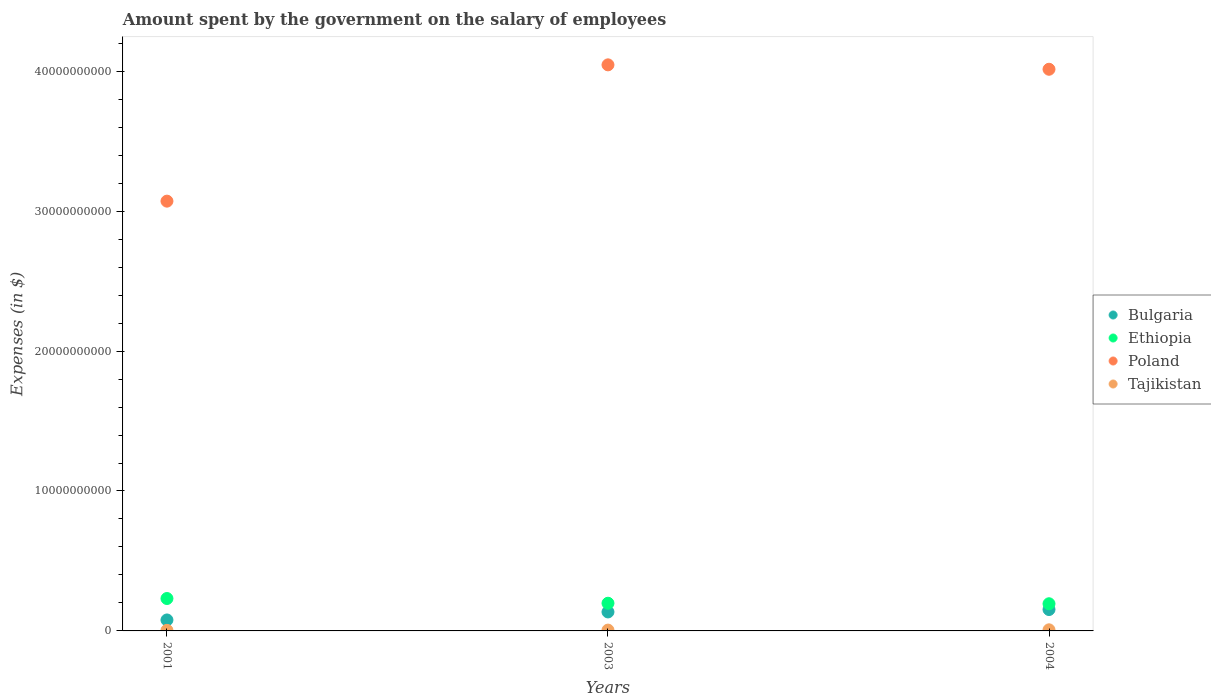Is the number of dotlines equal to the number of legend labels?
Ensure brevity in your answer.  Yes. What is the amount spent on the salary of employees by the government in Poland in 2001?
Make the answer very short. 3.07e+1. Across all years, what is the maximum amount spent on the salary of employees by the government in Tajikistan?
Provide a short and direct response. 7.91e+07. Across all years, what is the minimum amount spent on the salary of employees by the government in Poland?
Ensure brevity in your answer.  3.07e+1. What is the total amount spent on the salary of employees by the government in Poland in the graph?
Ensure brevity in your answer.  1.11e+11. What is the difference between the amount spent on the salary of employees by the government in Poland in 2003 and that in 2004?
Offer a very short reply. 3.15e+08. What is the difference between the amount spent on the salary of employees by the government in Ethiopia in 2004 and the amount spent on the salary of employees by the government in Bulgaria in 2003?
Keep it short and to the point. 5.86e+08. What is the average amount spent on the salary of employees by the government in Bulgaria per year?
Offer a terse response. 1.22e+09. In the year 2001, what is the difference between the amount spent on the salary of employees by the government in Bulgaria and amount spent on the salary of employees by the government in Poland?
Make the answer very short. -2.99e+1. In how many years, is the amount spent on the salary of employees by the government in Tajikistan greater than 34000000000 $?
Keep it short and to the point. 0. What is the ratio of the amount spent on the salary of employees by the government in Tajikistan in 2001 to that in 2003?
Ensure brevity in your answer.  0.69. What is the difference between the highest and the second highest amount spent on the salary of employees by the government in Tajikistan?
Give a very brief answer. 2.00e+07. What is the difference between the highest and the lowest amount spent on the salary of employees by the government in Bulgaria?
Provide a succinct answer. 7.45e+08. In how many years, is the amount spent on the salary of employees by the government in Ethiopia greater than the average amount spent on the salary of employees by the government in Ethiopia taken over all years?
Provide a succinct answer. 1. Is it the case that in every year, the sum of the amount spent on the salary of employees by the government in Ethiopia and amount spent on the salary of employees by the government in Bulgaria  is greater than the sum of amount spent on the salary of employees by the government in Poland and amount spent on the salary of employees by the government in Tajikistan?
Provide a short and direct response. No. Is it the case that in every year, the sum of the amount spent on the salary of employees by the government in Tajikistan and amount spent on the salary of employees by the government in Ethiopia  is greater than the amount spent on the salary of employees by the government in Bulgaria?
Make the answer very short. Yes. Does the amount spent on the salary of employees by the government in Poland monotonically increase over the years?
Offer a very short reply. No. Is the amount spent on the salary of employees by the government in Bulgaria strictly greater than the amount spent on the salary of employees by the government in Poland over the years?
Give a very brief answer. No. Is the amount spent on the salary of employees by the government in Tajikistan strictly less than the amount spent on the salary of employees by the government in Ethiopia over the years?
Your answer should be compact. Yes. What is the difference between two consecutive major ticks on the Y-axis?
Provide a succinct answer. 1.00e+1. Are the values on the major ticks of Y-axis written in scientific E-notation?
Offer a terse response. No. How many legend labels are there?
Ensure brevity in your answer.  4. What is the title of the graph?
Offer a very short reply. Amount spent by the government on the salary of employees. Does "St. Kitts and Nevis" appear as one of the legend labels in the graph?
Give a very brief answer. No. What is the label or title of the Y-axis?
Make the answer very short. Expenses (in $). What is the Expenses (in $) of Bulgaria in 2001?
Offer a very short reply. 7.83e+08. What is the Expenses (in $) in Ethiopia in 2001?
Your answer should be compact. 2.32e+09. What is the Expenses (in $) in Poland in 2001?
Provide a short and direct response. 3.07e+1. What is the Expenses (in $) of Tajikistan in 2001?
Your response must be concise. 4.09e+07. What is the Expenses (in $) in Bulgaria in 2003?
Your answer should be very brief. 1.36e+09. What is the Expenses (in $) in Ethiopia in 2003?
Your response must be concise. 1.98e+09. What is the Expenses (in $) of Poland in 2003?
Make the answer very short. 4.05e+1. What is the Expenses (in $) in Tajikistan in 2003?
Your answer should be compact. 5.91e+07. What is the Expenses (in $) in Bulgaria in 2004?
Your answer should be very brief. 1.53e+09. What is the Expenses (in $) of Ethiopia in 2004?
Ensure brevity in your answer.  1.94e+09. What is the Expenses (in $) in Poland in 2004?
Your answer should be compact. 4.01e+1. What is the Expenses (in $) of Tajikistan in 2004?
Your answer should be compact. 7.91e+07. Across all years, what is the maximum Expenses (in $) of Bulgaria?
Provide a short and direct response. 1.53e+09. Across all years, what is the maximum Expenses (in $) of Ethiopia?
Ensure brevity in your answer.  2.32e+09. Across all years, what is the maximum Expenses (in $) of Poland?
Make the answer very short. 4.05e+1. Across all years, what is the maximum Expenses (in $) of Tajikistan?
Offer a terse response. 7.91e+07. Across all years, what is the minimum Expenses (in $) of Bulgaria?
Provide a short and direct response. 7.83e+08. Across all years, what is the minimum Expenses (in $) of Ethiopia?
Offer a terse response. 1.94e+09. Across all years, what is the minimum Expenses (in $) of Poland?
Make the answer very short. 3.07e+1. Across all years, what is the minimum Expenses (in $) of Tajikistan?
Offer a terse response. 4.09e+07. What is the total Expenses (in $) of Bulgaria in the graph?
Provide a short and direct response. 3.67e+09. What is the total Expenses (in $) in Ethiopia in the graph?
Offer a very short reply. 6.24e+09. What is the total Expenses (in $) in Poland in the graph?
Ensure brevity in your answer.  1.11e+11. What is the total Expenses (in $) of Tajikistan in the graph?
Keep it short and to the point. 1.79e+08. What is the difference between the Expenses (in $) of Bulgaria in 2001 and that in 2003?
Offer a terse response. -5.72e+08. What is the difference between the Expenses (in $) of Ethiopia in 2001 and that in 2003?
Offer a very short reply. 3.38e+08. What is the difference between the Expenses (in $) in Poland in 2001 and that in 2003?
Provide a short and direct response. -9.74e+09. What is the difference between the Expenses (in $) of Tajikistan in 2001 and that in 2003?
Offer a very short reply. -1.82e+07. What is the difference between the Expenses (in $) in Bulgaria in 2001 and that in 2004?
Provide a succinct answer. -7.45e+08. What is the difference between the Expenses (in $) of Ethiopia in 2001 and that in 2004?
Ensure brevity in your answer.  3.74e+08. What is the difference between the Expenses (in $) in Poland in 2001 and that in 2004?
Your answer should be very brief. -9.42e+09. What is the difference between the Expenses (in $) in Tajikistan in 2001 and that in 2004?
Your response must be concise. -3.82e+07. What is the difference between the Expenses (in $) in Bulgaria in 2003 and that in 2004?
Provide a succinct answer. -1.73e+08. What is the difference between the Expenses (in $) of Ethiopia in 2003 and that in 2004?
Your answer should be very brief. 3.68e+07. What is the difference between the Expenses (in $) of Poland in 2003 and that in 2004?
Provide a succinct answer. 3.15e+08. What is the difference between the Expenses (in $) in Tajikistan in 2003 and that in 2004?
Your answer should be very brief. -2.00e+07. What is the difference between the Expenses (in $) of Bulgaria in 2001 and the Expenses (in $) of Ethiopia in 2003?
Make the answer very short. -1.19e+09. What is the difference between the Expenses (in $) in Bulgaria in 2001 and the Expenses (in $) in Poland in 2003?
Make the answer very short. -3.97e+1. What is the difference between the Expenses (in $) in Bulgaria in 2001 and the Expenses (in $) in Tajikistan in 2003?
Your answer should be very brief. 7.24e+08. What is the difference between the Expenses (in $) of Ethiopia in 2001 and the Expenses (in $) of Poland in 2003?
Provide a succinct answer. -3.81e+1. What is the difference between the Expenses (in $) of Ethiopia in 2001 and the Expenses (in $) of Tajikistan in 2003?
Keep it short and to the point. 2.26e+09. What is the difference between the Expenses (in $) of Poland in 2001 and the Expenses (in $) of Tajikistan in 2003?
Give a very brief answer. 3.07e+1. What is the difference between the Expenses (in $) in Bulgaria in 2001 and the Expenses (in $) in Ethiopia in 2004?
Your response must be concise. -1.16e+09. What is the difference between the Expenses (in $) in Bulgaria in 2001 and the Expenses (in $) in Poland in 2004?
Your response must be concise. -3.94e+1. What is the difference between the Expenses (in $) in Bulgaria in 2001 and the Expenses (in $) in Tajikistan in 2004?
Your answer should be very brief. 7.04e+08. What is the difference between the Expenses (in $) in Ethiopia in 2001 and the Expenses (in $) in Poland in 2004?
Provide a succinct answer. -3.78e+1. What is the difference between the Expenses (in $) in Ethiopia in 2001 and the Expenses (in $) in Tajikistan in 2004?
Your response must be concise. 2.24e+09. What is the difference between the Expenses (in $) in Poland in 2001 and the Expenses (in $) in Tajikistan in 2004?
Give a very brief answer. 3.06e+1. What is the difference between the Expenses (in $) of Bulgaria in 2003 and the Expenses (in $) of Ethiopia in 2004?
Give a very brief answer. -5.86e+08. What is the difference between the Expenses (in $) of Bulgaria in 2003 and the Expenses (in $) of Poland in 2004?
Offer a terse response. -3.88e+1. What is the difference between the Expenses (in $) of Bulgaria in 2003 and the Expenses (in $) of Tajikistan in 2004?
Offer a terse response. 1.28e+09. What is the difference between the Expenses (in $) in Ethiopia in 2003 and the Expenses (in $) in Poland in 2004?
Your answer should be very brief. -3.82e+1. What is the difference between the Expenses (in $) in Ethiopia in 2003 and the Expenses (in $) in Tajikistan in 2004?
Your response must be concise. 1.90e+09. What is the difference between the Expenses (in $) of Poland in 2003 and the Expenses (in $) of Tajikistan in 2004?
Your answer should be compact. 4.04e+1. What is the average Expenses (in $) in Bulgaria per year?
Give a very brief answer. 1.22e+09. What is the average Expenses (in $) of Ethiopia per year?
Ensure brevity in your answer.  2.08e+09. What is the average Expenses (in $) of Poland per year?
Offer a terse response. 3.71e+1. What is the average Expenses (in $) of Tajikistan per year?
Provide a succinct answer. 5.97e+07. In the year 2001, what is the difference between the Expenses (in $) in Bulgaria and Expenses (in $) in Ethiopia?
Ensure brevity in your answer.  -1.53e+09. In the year 2001, what is the difference between the Expenses (in $) of Bulgaria and Expenses (in $) of Poland?
Ensure brevity in your answer.  -2.99e+1. In the year 2001, what is the difference between the Expenses (in $) of Bulgaria and Expenses (in $) of Tajikistan?
Make the answer very short. 7.42e+08. In the year 2001, what is the difference between the Expenses (in $) in Ethiopia and Expenses (in $) in Poland?
Offer a terse response. -2.84e+1. In the year 2001, what is the difference between the Expenses (in $) in Ethiopia and Expenses (in $) in Tajikistan?
Offer a terse response. 2.27e+09. In the year 2001, what is the difference between the Expenses (in $) in Poland and Expenses (in $) in Tajikistan?
Provide a short and direct response. 3.07e+1. In the year 2003, what is the difference between the Expenses (in $) of Bulgaria and Expenses (in $) of Ethiopia?
Your response must be concise. -6.23e+08. In the year 2003, what is the difference between the Expenses (in $) in Bulgaria and Expenses (in $) in Poland?
Your response must be concise. -3.91e+1. In the year 2003, what is the difference between the Expenses (in $) in Bulgaria and Expenses (in $) in Tajikistan?
Your response must be concise. 1.30e+09. In the year 2003, what is the difference between the Expenses (in $) of Ethiopia and Expenses (in $) of Poland?
Your answer should be compact. -3.85e+1. In the year 2003, what is the difference between the Expenses (in $) in Ethiopia and Expenses (in $) in Tajikistan?
Make the answer very short. 1.92e+09. In the year 2003, what is the difference between the Expenses (in $) in Poland and Expenses (in $) in Tajikistan?
Your answer should be compact. 4.04e+1. In the year 2004, what is the difference between the Expenses (in $) in Bulgaria and Expenses (in $) in Ethiopia?
Keep it short and to the point. -4.13e+08. In the year 2004, what is the difference between the Expenses (in $) of Bulgaria and Expenses (in $) of Poland?
Keep it short and to the point. -3.86e+1. In the year 2004, what is the difference between the Expenses (in $) of Bulgaria and Expenses (in $) of Tajikistan?
Provide a succinct answer. 1.45e+09. In the year 2004, what is the difference between the Expenses (in $) in Ethiopia and Expenses (in $) in Poland?
Offer a terse response. -3.82e+1. In the year 2004, what is the difference between the Expenses (in $) in Ethiopia and Expenses (in $) in Tajikistan?
Keep it short and to the point. 1.86e+09. In the year 2004, what is the difference between the Expenses (in $) in Poland and Expenses (in $) in Tajikistan?
Ensure brevity in your answer.  4.01e+1. What is the ratio of the Expenses (in $) of Bulgaria in 2001 to that in 2003?
Offer a very short reply. 0.58. What is the ratio of the Expenses (in $) in Ethiopia in 2001 to that in 2003?
Offer a terse response. 1.17. What is the ratio of the Expenses (in $) in Poland in 2001 to that in 2003?
Your response must be concise. 0.76. What is the ratio of the Expenses (in $) in Tajikistan in 2001 to that in 2003?
Offer a very short reply. 0.69. What is the ratio of the Expenses (in $) of Bulgaria in 2001 to that in 2004?
Ensure brevity in your answer.  0.51. What is the ratio of the Expenses (in $) of Ethiopia in 2001 to that in 2004?
Your answer should be very brief. 1.19. What is the ratio of the Expenses (in $) in Poland in 2001 to that in 2004?
Offer a very short reply. 0.77. What is the ratio of the Expenses (in $) in Tajikistan in 2001 to that in 2004?
Your answer should be very brief. 0.52. What is the ratio of the Expenses (in $) in Bulgaria in 2003 to that in 2004?
Keep it short and to the point. 0.89. What is the ratio of the Expenses (in $) in Poland in 2003 to that in 2004?
Provide a short and direct response. 1.01. What is the ratio of the Expenses (in $) in Tajikistan in 2003 to that in 2004?
Provide a succinct answer. 0.75. What is the difference between the highest and the second highest Expenses (in $) of Bulgaria?
Give a very brief answer. 1.73e+08. What is the difference between the highest and the second highest Expenses (in $) of Ethiopia?
Keep it short and to the point. 3.38e+08. What is the difference between the highest and the second highest Expenses (in $) of Poland?
Ensure brevity in your answer.  3.15e+08. What is the difference between the highest and the second highest Expenses (in $) in Tajikistan?
Your answer should be compact. 2.00e+07. What is the difference between the highest and the lowest Expenses (in $) in Bulgaria?
Ensure brevity in your answer.  7.45e+08. What is the difference between the highest and the lowest Expenses (in $) in Ethiopia?
Your answer should be very brief. 3.74e+08. What is the difference between the highest and the lowest Expenses (in $) in Poland?
Ensure brevity in your answer.  9.74e+09. What is the difference between the highest and the lowest Expenses (in $) in Tajikistan?
Your answer should be very brief. 3.82e+07. 